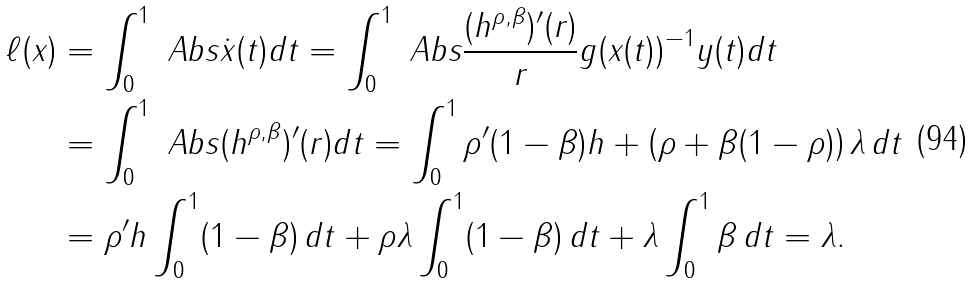Convert formula to latex. <formula><loc_0><loc_0><loc_500><loc_500>\ell ( x ) & = \int _ { 0 } ^ { 1 } \ A b s { \dot { x } ( t ) } d t = \int _ { 0 } ^ { 1 } \ A b s { \frac { ( h ^ { \rho , \beta } ) ^ { \prime } ( r ) } { r } g ( x ( t ) ) ^ { - 1 } y ( t ) } d t \\ & = \int _ { 0 } ^ { 1 } \ A b s { ( h ^ { \rho , \beta } ) ^ { \prime } ( r ) } d t = \int _ { 0 } ^ { 1 } \rho ^ { \prime } ( 1 - \beta ) h + \left ( \rho + \beta ( 1 - \rho ) \right ) \lambda \, d t \\ & = \rho ^ { \prime } h \int _ { 0 } ^ { 1 } ( 1 - \beta ) \, d t + \rho \lambda \int _ { 0 } ^ { 1 } ( 1 - \beta ) \, d t + \lambda \int _ { 0 } ^ { 1 } \beta \, d t = \lambda .</formula> 